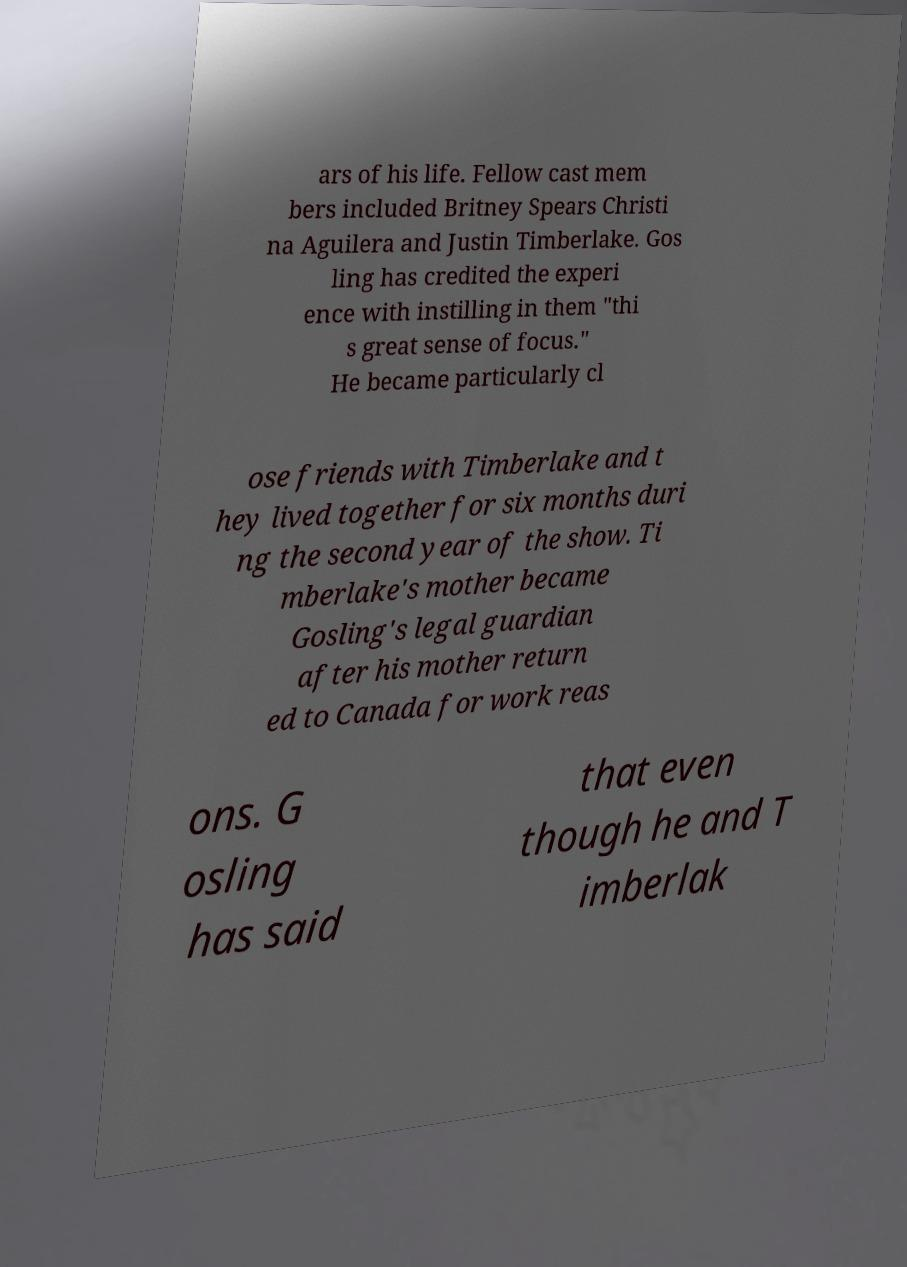Can you accurately transcribe the text from the provided image for me? ars of his life. Fellow cast mem bers included Britney Spears Christi na Aguilera and Justin Timberlake. Gos ling has credited the experi ence with instilling in them "thi s great sense of focus." He became particularly cl ose friends with Timberlake and t hey lived together for six months duri ng the second year of the show. Ti mberlake's mother became Gosling's legal guardian after his mother return ed to Canada for work reas ons. G osling has said that even though he and T imberlak 